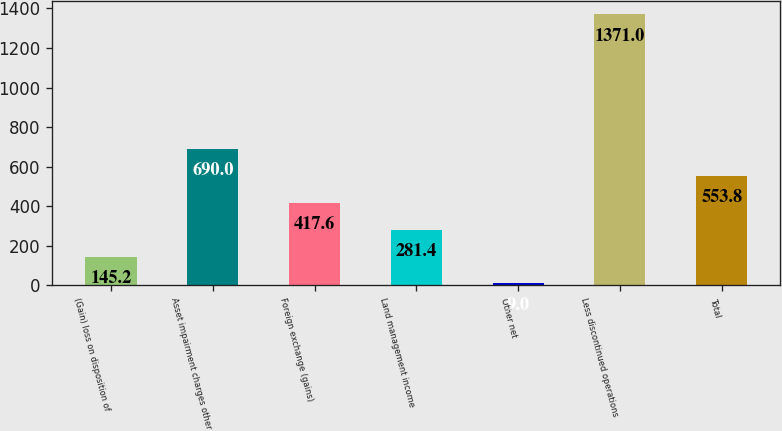Convert chart to OTSL. <chart><loc_0><loc_0><loc_500><loc_500><bar_chart><fcel>(Gain) loss on disposition of<fcel>Asset impairment charges other<fcel>Foreign exchange (gains)<fcel>Land management income<fcel>Other net<fcel>Less discontinued operations<fcel>Total<nl><fcel>145.2<fcel>690<fcel>417.6<fcel>281.4<fcel>9<fcel>1371<fcel>553.8<nl></chart> 